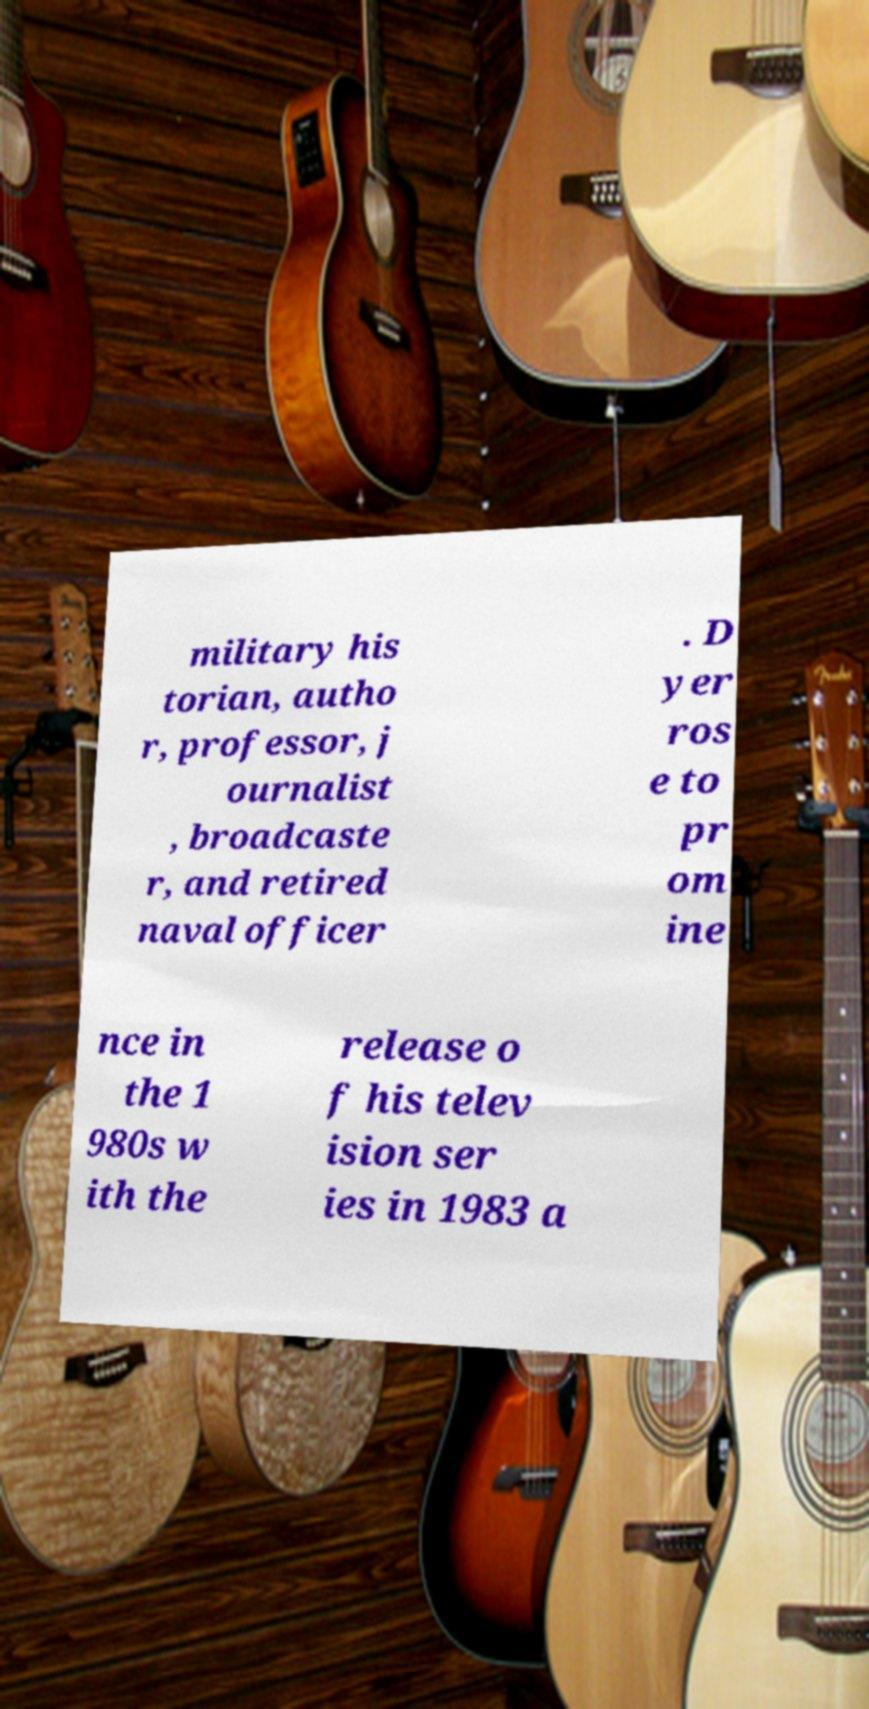There's text embedded in this image that I need extracted. Can you transcribe it verbatim? military his torian, autho r, professor, j ournalist , broadcaste r, and retired naval officer . D yer ros e to pr om ine nce in the 1 980s w ith the release o f his telev ision ser ies in 1983 a 